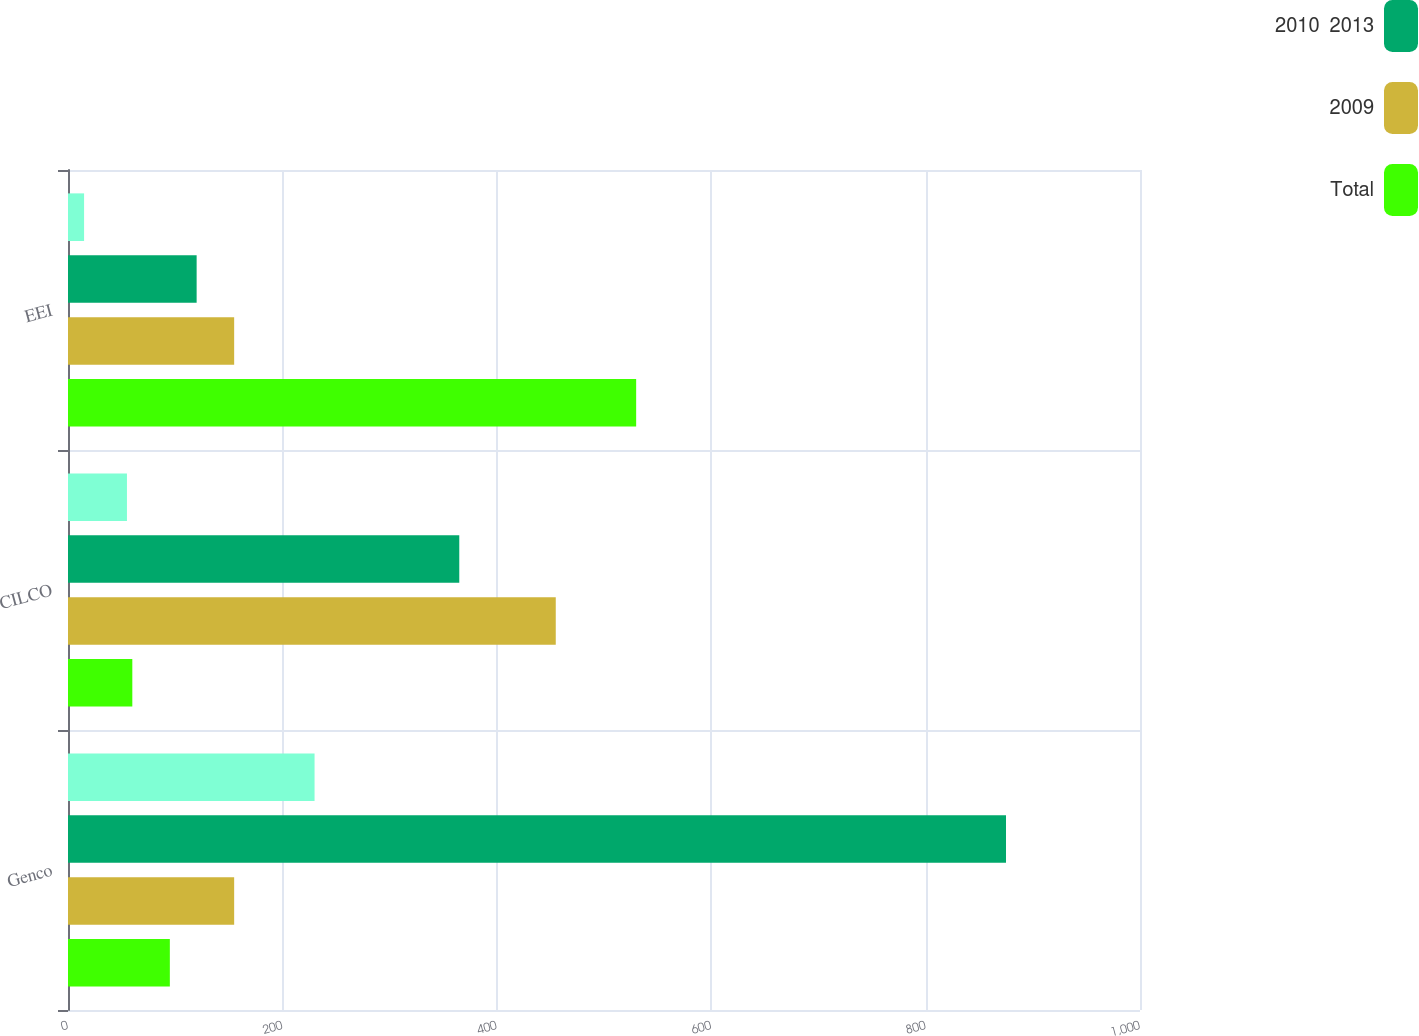<chart> <loc_0><loc_0><loc_500><loc_500><stacked_bar_chart><ecel><fcel>Genco<fcel>CILCO<fcel>EEI<nl><fcel>nan<fcel>230<fcel>55<fcel>15<nl><fcel>2010  2013<fcel>875<fcel>365<fcel>120<nl><fcel>2009<fcel>155<fcel>455<fcel>155<nl><fcel>Total<fcel>95<fcel>60<fcel>530<nl></chart> 